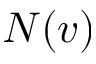Convert formula to latex. <formula><loc_0><loc_0><loc_500><loc_500>N ( v )</formula> 